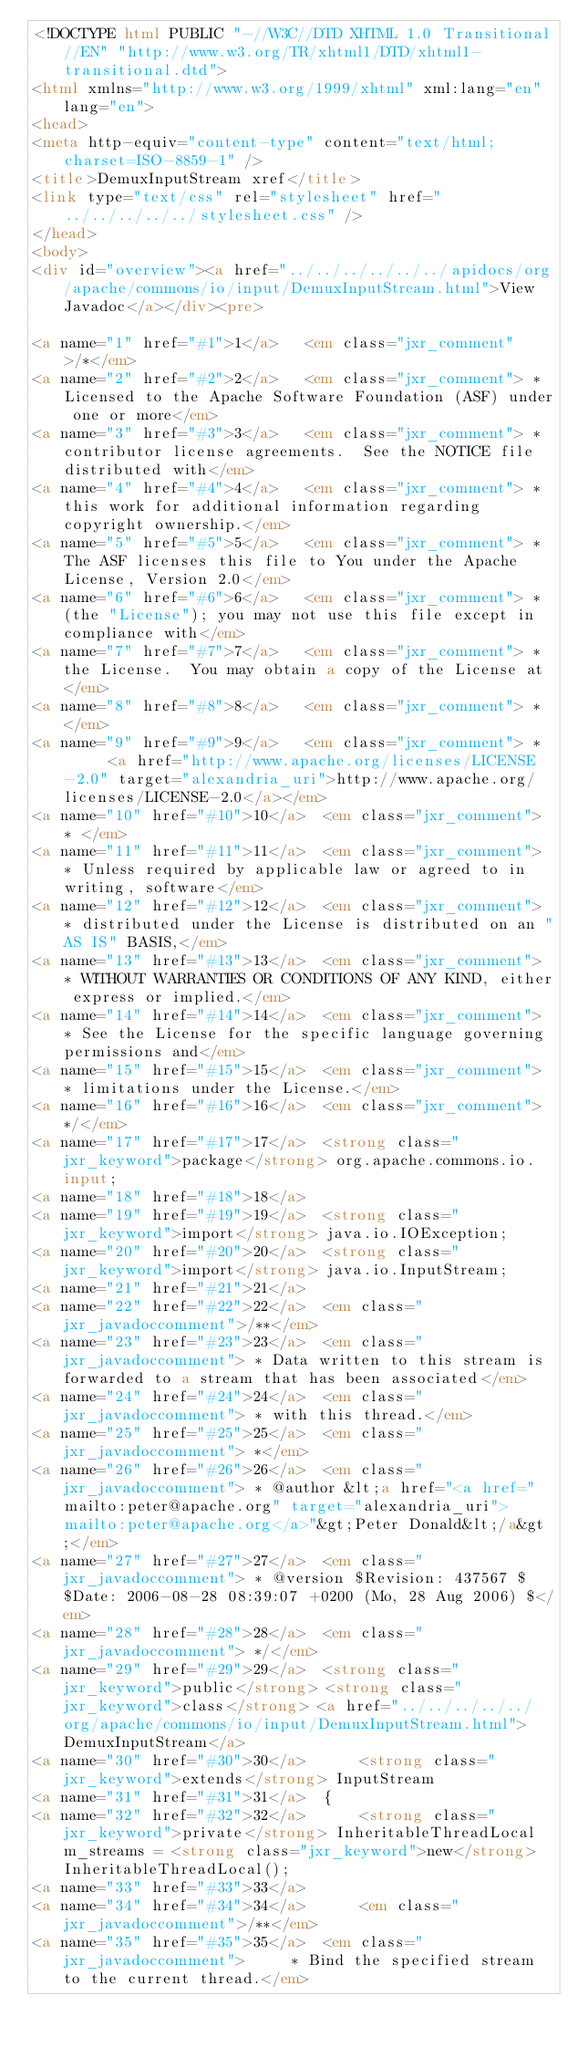<code> <loc_0><loc_0><loc_500><loc_500><_HTML_><!DOCTYPE html PUBLIC "-//W3C//DTD XHTML 1.0 Transitional//EN" "http://www.w3.org/TR/xhtml1/DTD/xhtml1-transitional.dtd">
<html xmlns="http://www.w3.org/1999/xhtml" xml:lang="en" lang="en">
<head>
<meta http-equiv="content-type" content="text/html; charset=ISO-8859-1" />
<title>DemuxInputStream xref</title>
<link type="text/css" rel="stylesheet" href="../../../../../stylesheet.css" />
</head>
<body>
<div id="overview"><a href="../../../../../../apidocs/org/apache/commons/io/input/DemuxInputStream.html">View Javadoc</a></div><pre>

<a name="1" href="#1">1</a>   <em class="jxr_comment">/*</em>
<a name="2" href="#2">2</a>   <em class="jxr_comment"> * Licensed to the Apache Software Foundation (ASF) under one or more</em>
<a name="3" href="#3">3</a>   <em class="jxr_comment"> * contributor license agreements.  See the NOTICE file distributed with</em>
<a name="4" href="#4">4</a>   <em class="jxr_comment"> * this work for additional information regarding copyright ownership.</em>
<a name="5" href="#5">5</a>   <em class="jxr_comment"> * The ASF licenses this file to You under the Apache License, Version 2.0</em>
<a name="6" href="#6">6</a>   <em class="jxr_comment"> * (the "License"); you may not use this file except in compliance with</em>
<a name="7" href="#7">7</a>   <em class="jxr_comment"> * the License.  You may obtain a copy of the License at</em>
<a name="8" href="#8">8</a>   <em class="jxr_comment"> * </em>
<a name="9" href="#9">9</a>   <em class="jxr_comment"> *      <a href="http://www.apache.org/licenses/LICENSE-2.0" target="alexandria_uri">http://www.apache.org/licenses/LICENSE-2.0</a></em>
<a name="10" href="#10">10</a>  <em class="jxr_comment"> * </em>
<a name="11" href="#11">11</a>  <em class="jxr_comment"> * Unless required by applicable law or agreed to in writing, software</em>
<a name="12" href="#12">12</a>  <em class="jxr_comment"> * distributed under the License is distributed on an "AS IS" BASIS,</em>
<a name="13" href="#13">13</a>  <em class="jxr_comment"> * WITHOUT WARRANTIES OR CONDITIONS OF ANY KIND, either express or implied.</em>
<a name="14" href="#14">14</a>  <em class="jxr_comment"> * See the License for the specific language governing permissions and</em>
<a name="15" href="#15">15</a>  <em class="jxr_comment"> * limitations under the License.</em>
<a name="16" href="#16">16</a>  <em class="jxr_comment"> */</em>
<a name="17" href="#17">17</a>  <strong class="jxr_keyword">package</strong> org.apache.commons.io.input;
<a name="18" href="#18">18</a>  
<a name="19" href="#19">19</a>  <strong class="jxr_keyword">import</strong> java.io.IOException;
<a name="20" href="#20">20</a>  <strong class="jxr_keyword">import</strong> java.io.InputStream;
<a name="21" href="#21">21</a>  
<a name="22" href="#22">22</a>  <em class="jxr_javadoccomment">/**</em>
<a name="23" href="#23">23</a>  <em class="jxr_javadoccomment"> * Data written to this stream is forwarded to a stream that has been associated</em>
<a name="24" href="#24">24</a>  <em class="jxr_javadoccomment"> * with this thread.</em>
<a name="25" href="#25">25</a>  <em class="jxr_javadoccomment"> *</em>
<a name="26" href="#26">26</a>  <em class="jxr_javadoccomment"> * @author &lt;a href="<a href="mailto:peter@apache.org" target="alexandria_uri">mailto:peter@apache.org</a>"&gt;Peter Donald&lt;/a&gt;</em>
<a name="27" href="#27">27</a>  <em class="jxr_javadoccomment"> * @version $Revision: 437567 $ $Date: 2006-08-28 08:39:07 +0200 (Mo, 28 Aug 2006) $</em>
<a name="28" href="#28">28</a>  <em class="jxr_javadoccomment"> */</em>
<a name="29" href="#29">29</a>  <strong class="jxr_keyword">public</strong> <strong class="jxr_keyword">class</strong> <a href="../../../../../org/apache/commons/io/input/DemuxInputStream.html">DemuxInputStream</a>
<a name="30" href="#30">30</a>      <strong class="jxr_keyword">extends</strong> InputStream
<a name="31" href="#31">31</a>  {
<a name="32" href="#32">32</a>      <strong class="jxr_keyword">private</strong> InheritableThreadLocal m_streams = <strong class="jxr_keyword">new</strong> InheritableThreadLocal();
<a name="33" href="#33">33</a>  
<a name="34" href="#34">34</a>      <em class="jxr_javadoccomment">/**</em>
<a name="35" href="#35">35</a>  <em class="jxr_javadoccomment">     * Bind the specified stream to the current thread.</em></code> 